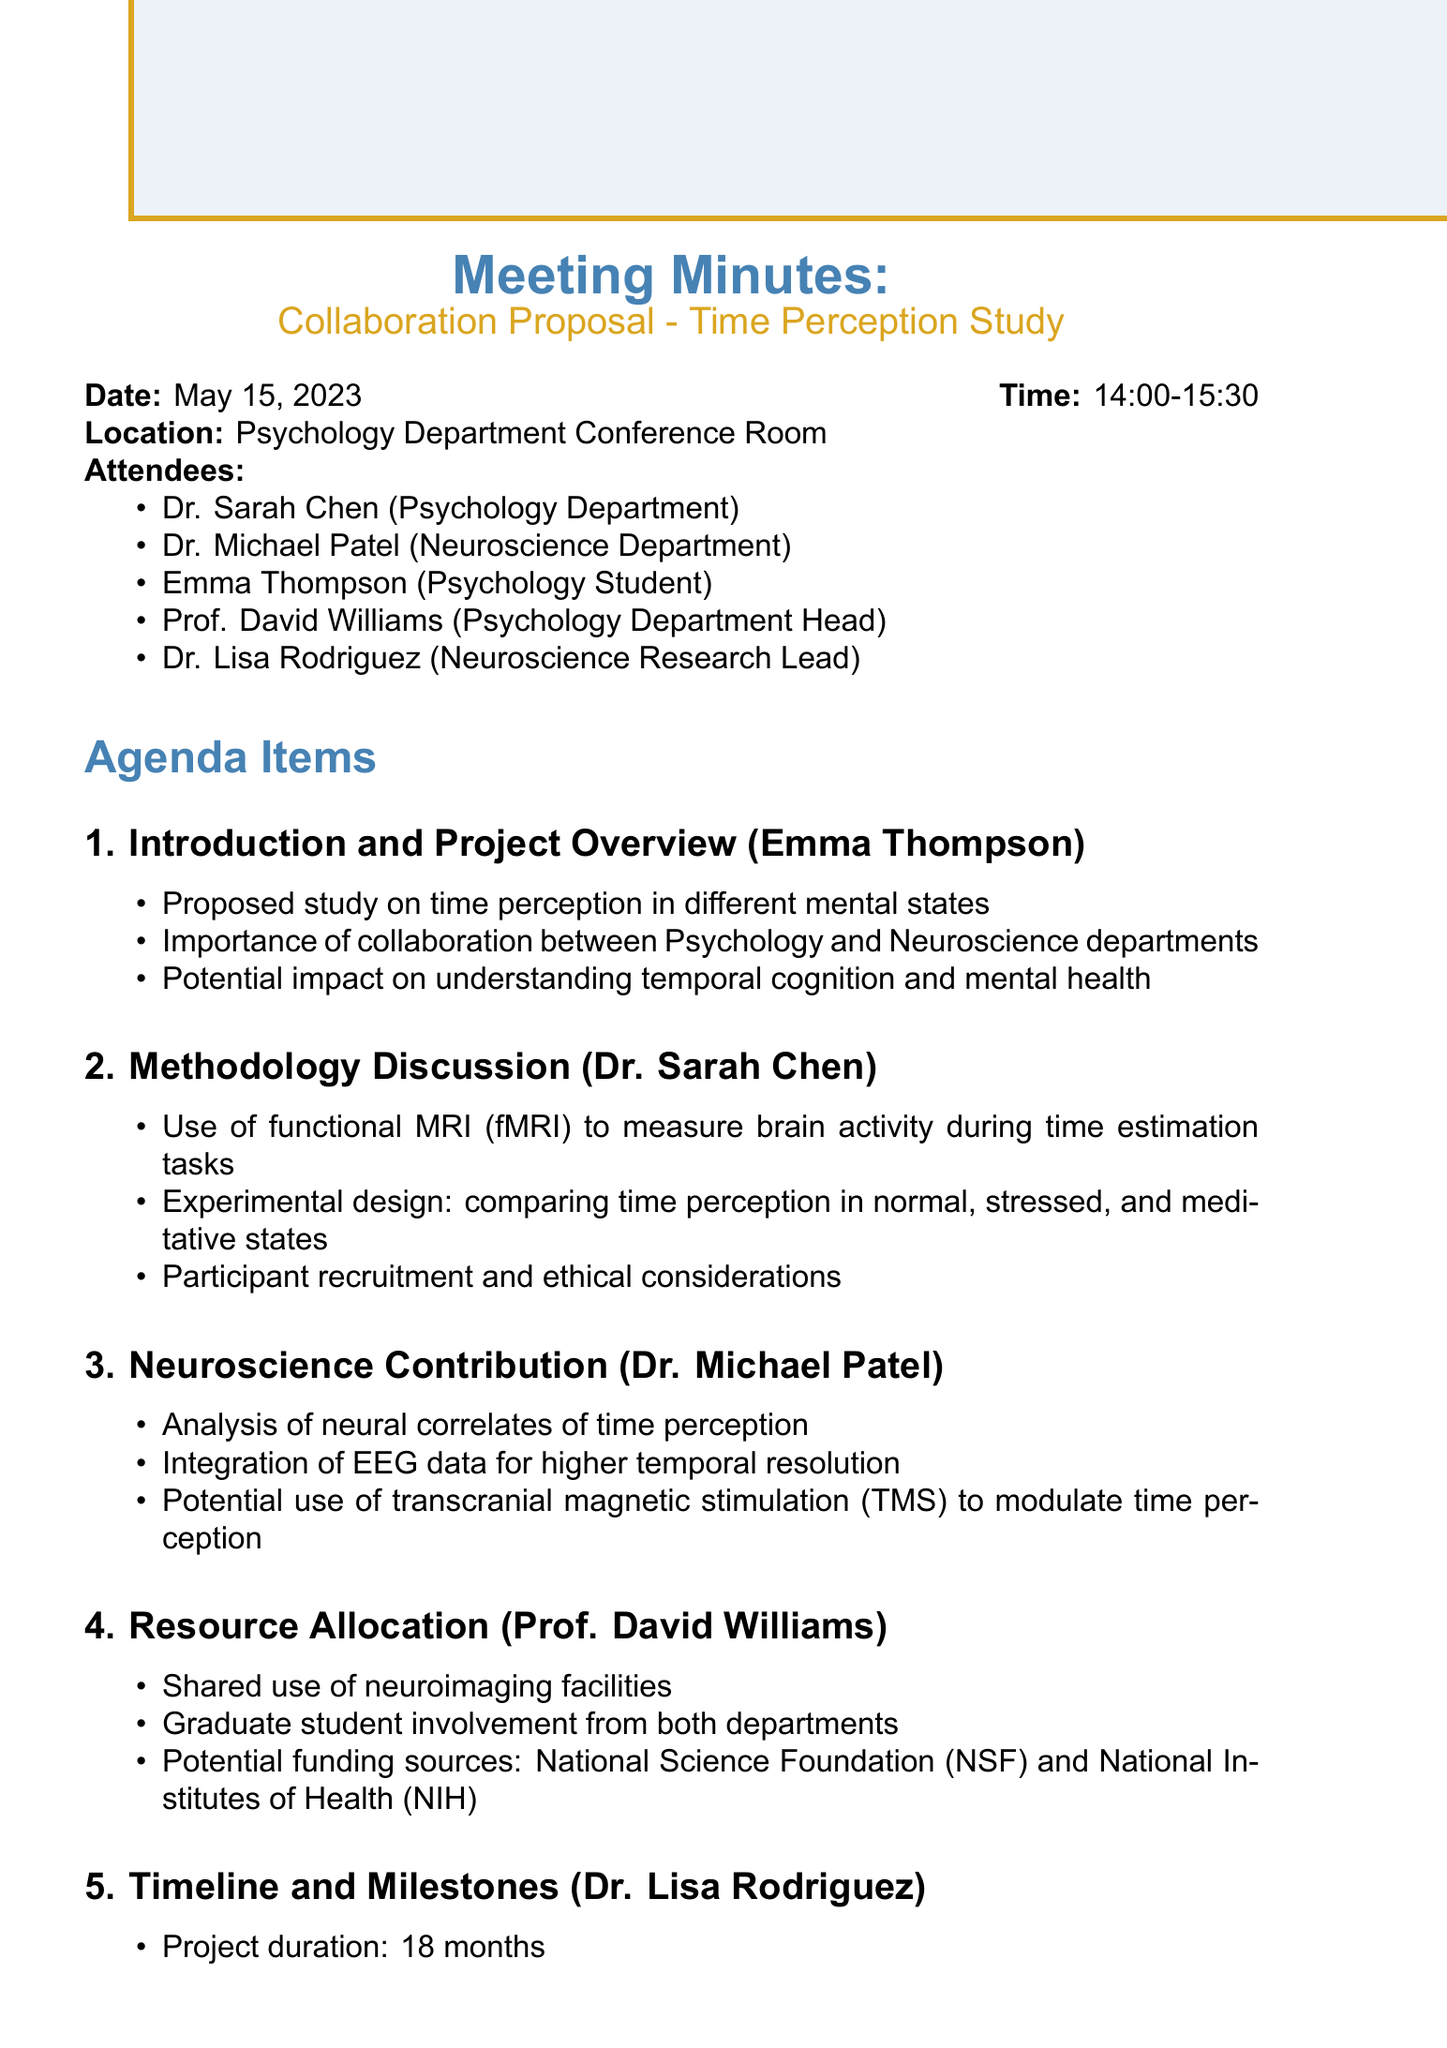What is the date of the meeting? The date of the meeting is explicitly stated in the document.
Answer: May 15, 2023 Who presented the Introduction and Project Overview? The document lists the presenters for each agenda item.
Answer: Emma Thompson What is the proposed study about? The key points mention the focus of the study in time perception.
Answer: Time perception in different mental states Which imaging technique will be used in the study? The methodology discusses the imaging techniques planned for the study.
Answer: Functional MRI (fMRI) What is the project duration? The timeline section specifies the length of the project.
Answer: 18 months Which potential funding sources were mentioned? The resource allocation section lists potential funding sources for the project.
Answer: National Science Foundation (NSF) and National Institutes of Health (NIH) What is one of the key milestones outlined in the timeline? The timeline includes specific milestones that the project aims to achieve.
Answer: IRB approval When is the next meeting scheduled? The action items state when the next meeting is planned.
Answer: June 30th 